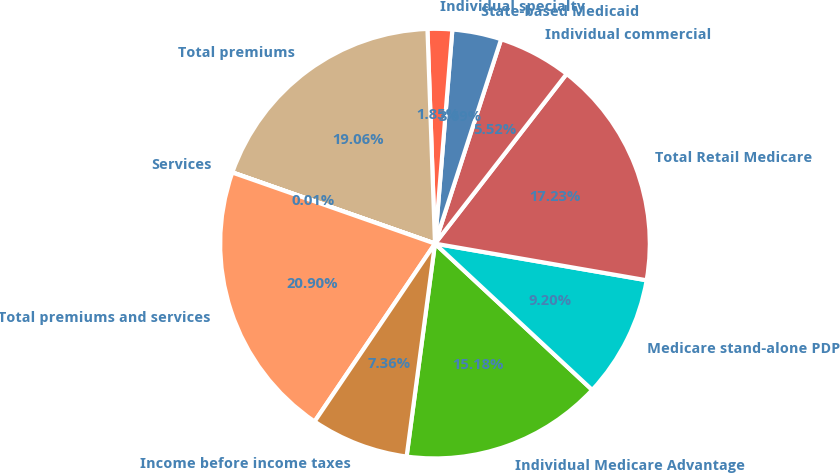Convert chart to OTSL. <chart><loc_0><loc_0><loc_500><loc_500><pie_chart><fcel>Individual Medicare Advantage<fcel>Medicare stand-alone PDP<fcel>Total Retail Medicare<fcel>Individual commercial<fcel>State-based Medicaid<fcel>Individual specialty<fcel>Total premiums<fcel>Services<fcel>Total premiums and services<fcel>Income before income taxes<nl><fcel>15.18%<fcel>9.2%<fcel>17.23%<fcel>5.52%<fcel>3.69%<fcel>1.85%<fcel>19.06%<fcel>0.01%<fcel>20.9%<fcel>7.36%<nl></chart> 